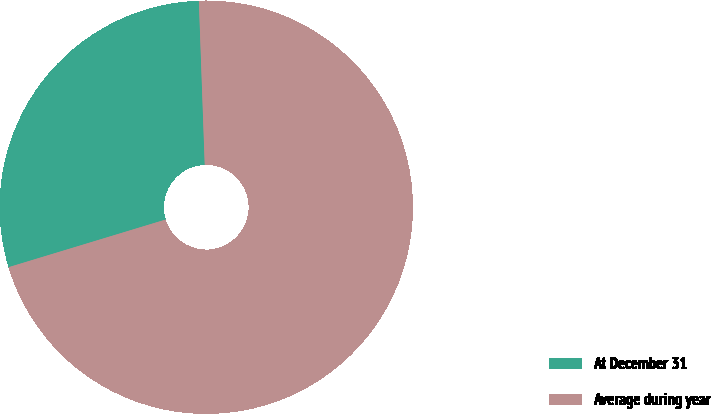Convert chart to OTSL. <chart><loc_0><loc_0><loc_500><loc_500><pie_chart><fcel>At December 31<fcel>Average during year<nl><fcel>29.12%<fcel>70.88%<nl></chart> 